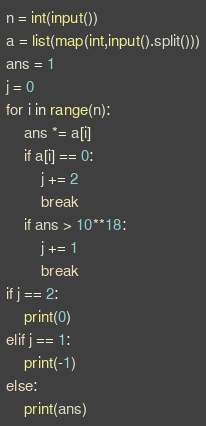<code> <loc_0><loc_0><loc_500><loc_500><_Python_>n = int(input())
a = list(map(int,input().split()))
ans = 1
j = 0
for i in range(n):
    ans *= a[i]
    if a[i] == 0:
        j += 2
        break
    if ans > 10**18:
        j += 1
        break
if j == 2:
    print(0)
elif j == 1:
    print(-1)
else:
    print(ans)</code> 